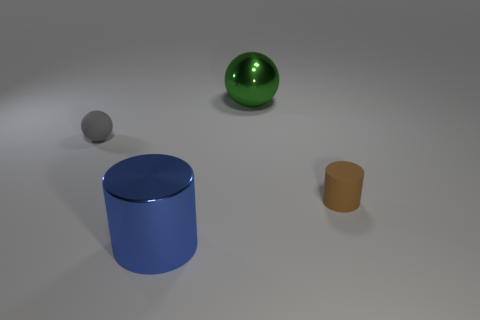What number of other things are the same color as the large metallic ball?
Offer a terse response. 0. There is a small thing right of the small object on the left side of the cylinder to the left of the tiny brown rubber thing; what is its material?
Give a very brief answer. Rubber. There is a tiny thing that is on the right side of the small thing that is to the left of the big blue shiny cylinder; what is it made of?
Provide a short and direct response. Rubber. Is the number of big things that are to the right of the big sphere less than the number of tiny yellow things?
Offer a terse response. No. What shape is the tiny matte thing behind the tiny brown matte thing?
Provide a short and direct response. Sphere. Does the gray thing have the same size as the matte object that is on the right side of the big blue cylinder?
Provide a short and direct response. Yes. Are there any cylinders made of the same material as the gray sphere?
Your response must be concise. Yes. What number of cylinders are either large red things or gray objects?
Make the answer very short. 0. Are there any large green things that are left of the small object that is left of the small brown rubber thing?
Your answer should be very brief. No. Is the number of large metal things less than the number of objects?
Provide a short and direct response. Yes. 